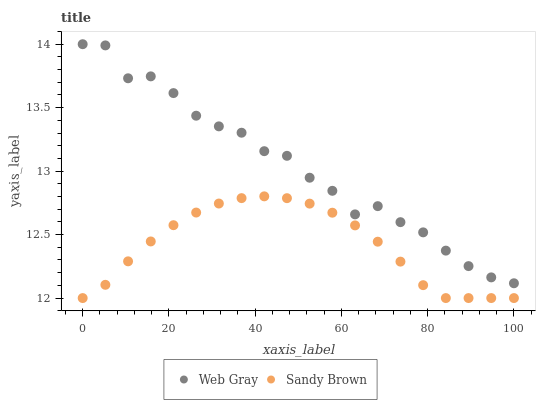Does Sandy Brown have the minimum area under the curve?
Answer yes or no. Yes. Does Web Gray have the maximum area under the curve?
Answer yes or no. Yes. Does Sandy Brown have the maximum area under the curve?
Answer yes or no. No. Is Sandy Brown the smoothest?
Answer yes or no. Yes. Is Web Gray the roughest?
Answer yes or no. Yes. Is Sandy Brown the roughest?
Answer yes or no. No. Does Sandy Brown have the lowest value?
Answer yes or no. Yes. Does Web Gray have the highest value?
Answer yes or no. Yes. Does Sandy Brown have the highest value?
Answer yes or no. No. Is Sandy Brown less than Web Gray?
Answer yes or no. Yes. Is Web Gray greater than Sandy Brown?
Answer yes or no. Yes. Does Sandy Brown intersect Web Gray?
Answer yes or no. No. 